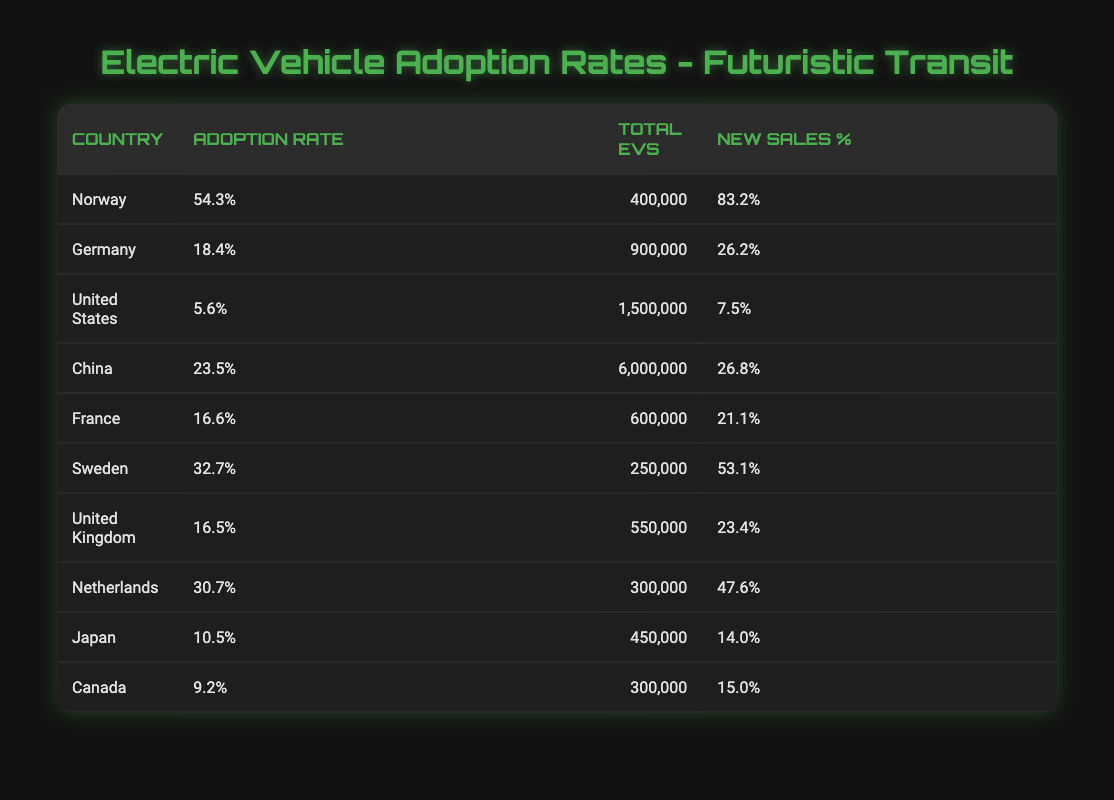What is the adoption rate percentage for Norway in 2022? The table lists Norway's adoption rate percentage for 2022 as 54.3%.
Answer: 54.3% Which country has the highest total number of electric vehicles in 2022? In the table, China is listed with a total of 6,000,000 electric vehicles in 2022, which is the highest among all countries presented.
Answer: China Is the new sales percentage for Sweden greater than 50%? The table shows that Sweden's new sales percentage is 53.1%, which is greater than 50%.
Answer: Yes What is the difference in adoption rates between Norway and the United States? Norway's adoption rate is 54.3%, and the United States' is 5.6%. The difference is 54.3 - 5.6 = 48.7%.
Answer: 48.7% Which countries have an adoption rate above 20% in 2022? The countries with an adoption rate above 20% are Norway (54.3%), China (23.5%), and Sweden (32.7%).
Answer: Norway, China, Sweden What is the average adoption rate of electric vehicles across the listed countries? The sum of the adoption rates for all countries is 54.3 + 18.4 + 5.6 + 23.5 + 16.6 + 32.7 + 16.5 + 30.7 + 10.5 + 9.2 = 217.9%, divided by 10 (the number of countries) gives an average of 21.79%.
Answer: 21.79% Does Canada have a higher new sales percentage compared to Japan? The table indicates Canada's new sales percentage is 15.0%, whereas Japan's is 14.0%. Therefore, Canada does have a higher new sales percentage than Japan.
Answer: Yes Which country has a total of 900,000 electric vehicles and what is its adoption rate percentage? The table shows Germany has a total of 900,000 electric vehicles in 2022 and an adoption rate percentage of 18.4%.
Answer: Germany, 18.4% 